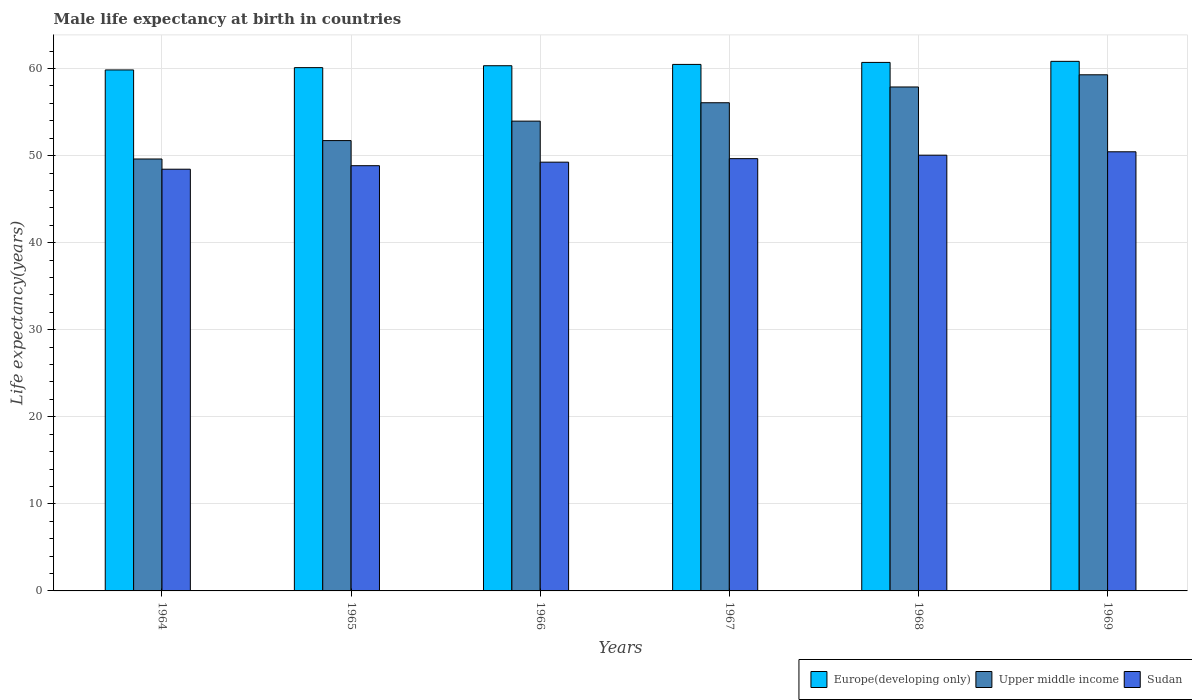How many different coloured bars are there?
Provide a succinct answer. 3. How many groups of bars are there?
Your answer should be compact. 6. Are the number of bars per tick equal to the number of legend labels?
Keep it short and to the point. Yes. Are the number of bars on each tick of the X-axis equal?
Your answer should be very brief. Yes. How many bars are there on the 6th tick from the left?
Offer a very short reply. 3. How many bars are there on the 2nd tick from the right?
Keep it short and to the point. 3. What is the label of the 6th group of bars from the left?
Keep it short and to the point. 1969. In how many cases, is the number of bars for a given year not equal to the number of legend labels?
Make the answer very short. 0. What is the male life expectancy at birth in Sudan in 1964?
Provide a short and direct response. 48.44. Across all years, what is the maximum male life expectancy at birth in Sudan?
Your answer should be very brief. 50.44. Across all years, what is the minimum male life expectancy at birth in Europe(developing only)?
Keep it short and to the point. 59.84. In which year was the male life expectancy at birth in Upper middle income maximum?
Make the answer very short. 1969. In which year was the male life expectancy at birth in Upper middle income minimum?
Provide a short and direct response. 1964. What is the total male life expectancy at birth in Sudan in the graph?
Your answer should be compact. 296.67. What is the difference between the male life expectancy at birth in Upper middle income in 1966 and that in 1969?
Give a very brief answer. -5.32. What is the difference between the male life expectancy at birth in Sudan in 1965 and the male life expectancy at birth in Upper middle income in 1964?
Give a very brief answer. -0.77. What is the average male life expectancy at birth in Sudan per year?
Your answer should be compact. 49.45. In the year 1966, what is the difference between the male life expectancy at birth in Sudan and male life expectancy at birth in Upper middle income?
Offer a very short reply. -4.71. In how many years, is the male life expectancy at birth in Europe(developing only) greater than 20 years?
Ensure brevity in your answer.  6. What is the ratio of the male life expectancy at birth in Sudan in 1966 to that in 1967?
Offer a very short reply. 0.99. Is the male life expectancy at birth in Upper middle income in 1966 less than that in 1969?
Your answer should be compact. Yes. What is the difference between the highest and the second highest male life expectancy at birth in Sudan?
Provide a succinct answer. 0.39. What is the difference between the highest and the lowest male life expectancy at birth in Sudan?
Give a very brief answer. 2. In how many years, is the male life expectancy at birth in Europe(developing only) greater than the average male life expectancy at birth in Europe(developing only) taken over all years?
Your answer should be compact. 3. Is the sum of the male life expectancy at birth in Sudan in 1964 and 1969 greater than the maximum male life expectancy at birth in Upper middle income across all years?
Make the answer very short. Yes. What does the 3rd bar from the left in 1966 represents?
Offer a very short reply. Sudan. What does the 3rd bar from the right in 1965 represents?
Your answer should be very brief. Europe(developing only). Is it the case that in every year, the sum of the male life expectancy at birth in Upper middle income and male life expectancy at birth in Europe(developing only) is greater than the male life expectancy at birth in Sudan?
Your response must be concise. Yes. How many bars are there?
Keep it short and to the point. 18. How many years are there in the graph?
Keep it short and to the point. 6. What is the difference between two consecutive major ticks on the Y-axis?
Your answer should be compact. 10. Does the graph contain grids?
Make the answer very short. Yes. How are the legend labels stacked?
Provide a succinct answer. Horizontal. What is the title of the graph?
Your answer should be very brief. Male life expectancy at birth in countries. Does "Niger" appear as one of the legend labels in the graph?
Your answer should be compact. No. What is the label or title of the Y-axis?
Your answer should be compact. Life expectancy(years). What is the Life expectancy(years) of Europe(developing only) in 1964?
Provide a succinct answer. 59.84. What is the Life expectancy(years) of Upper middle income in 1964?
Give a very brief answer. 49.61. What is the Life expectancy(years) in Sudan in 1964?
Make the answer very short. 48.44. What is the Life expectancy(years) in Europe(developing only) in 1965?
Your response must be concise. 60.11. What is the Life expectancy(years) of Upper middle income in 1965?
Keep it short and to the point. 51.73. What is the Life expectancy(years) in Sudan in 1965?
Keep it short and to the point. 48.84. What is the Life expectancy(years) in Europe(developing only) in 1966?
Provide a short and direct response. 60.33. What is the Life expectancy(years) in Upper middle income in 1966?
Your answer should be very brief. 53.96. What is the Life expectancy(years) in Sudan in 1966?
Your answer should be compact. 49.25. What is the Life expectancy(years) in Europe(developing only) in 1967?
Offer a terse response. 60.48. What is the Life expectancy(years) of Upper middle income in 1967?
Keep it short and to the point. 56.07. What is the Life expectancy(years) of Sudan in 1967?
Offer a very short reply. 49.65. What is the Life expectancy(years) of Europe(developing only) in 1968?
Offer a terse response. 60.71. What is the Life expectancy(years) of Upper middle income in 1968?
Your response must be concise. 57.89. What is the Life expectancy(years) in Sudan in 1968?
Your response must be concise. 50.05. What is the Life expectancy(years) of Europe(developing only) in 1969?
Provide a succinct answer. 60.83. What is the Life expectancy(years) of Upper middle income in 1969?
Your answer should be very brief. 59.28. What is the Life expectancy(years) of Sudan in 1969?
Give a very brief answer. 50.44. Across all years, what is the maximum Life expectancy(years) in Europe(developing only)?
Make the answer very short. 60.83. Across all years, what is the maximum Life expectancy(years) of Upper middle income?
Keep it short and to the point. 59.28. Across all years, what is the maximum Life expectancy(years) in Sudan?
Your answer should be very brief. 50.44. Across all years, what is the minimum Life expectancy(years) in Europe(developing only)?
Your answer should be compact. 59.84. Across all years, what is the minimum Life expectancy(years) in Upper middle income?
Provide a short and direct response. 49.61. Across all years, what is the minimum Life expectancy(years) of Sudan?
Offer a terse response. 48.44. What is the total Life expectancy(years) of Europe(developing only) in the graph?
Make the answer very short. 362.29. What is the total Life expectancy(years) in Upper middle income in the graph?
Provide a succinct answer. 328.55. What is the total Life expectancy(years) in Sudan in the graph?
Your answer should be compact. 296.67. What is the difference between the Life expectancy(years) in Europe(developing only) in 1964 and that in 1965?
Give a very brief answer. -0.27. What is the difference between the Life expectancy(years) of Upper middle income in 1964 and that in 1965?
Ensure brevity in your answer.  -2.11. What is the difference between the Life expectancy(years) in Sudan in 1964 and that in 1965?
Give a very brief answer. -0.4. What is the difference between the Life expectancy(years) of Europe(developing only) in 1964 and that in 1966?
Give a very brief answer. -0.48. What is the difference between the Life expectancy(years) in Upper middle income in 1964 and that in 1966?
Offer a terse response. -4.35. What is the difference between the Life expectancy(years) in Sudan in 1964 and that in 1966?
Make the answer very short. -0.81. What is the difference between the Life expectancy(years) of Europe(developing only) in 1964 and that in 1967?
Provide a short and direct response. -0.64. What is the difference between the Life expectancy(years) in Upper middle income in 1964 and that in 1967?
Offer a terse response. -6.46. What is the difference between the Life expectancy(years) in Sudan in 1964 and that in 1967?
Your answer should be very brief. -1.21. What is the difference between the Life expectancy(years) in Europe(developing only) in 1964 and that in 1968?
Your answer should be very brief. -0.86. What is the difference between the Life expectancy(years) in Upper middle income in 1964 and that in 1968?
Make the answer very short. -8.27. What is the difference between the Life expectancy(years) in Sudan in 1964 and that in 1968?
Offer a terse response. -1.61. What is the difference between the Life expectancy(years) in Europe(developing only) in 1964 and that in 1969?
Give a very brief answer. -0.99. What is the difference between the Life expectancy(years) in Upper middle income in 1964 and that in 1969?
Make the answer very short. -9.67. What is the difference between the Life expectancy(years) of Sudan in 1964 and that in 1969?
Ensure brevity in your answer.  -2. What is the difference between the Life expectancy(years) in Europe(developing only) in 1965 and that in 1966?
Provide a succinct answer. -0.22. What is the difference between the Life expectancy(years) in Upper middle income in 1965 and that in 1966?
Ensure brevity in your answer.  -2.24. What is the difference between the Life expectancy(years) in Sudan in 1965 and that in 1966?
Your answer should be very brief. -0.41. What is the difference between the Life expectancy(years) in Europe(developing only) in 1965 and that in 1967?
Your answer should be compact. -0.37. What is the difference between the Life expectancy(years) in Upper middle income in 1965 and that in 1967?
Your answer should be compact. -4.35. What is the difference between the Life expectancy(years) of Sudan in 1965 and that in 1967?
Keep it short and to the point. -0.81. What is the difference between the Life expectancy(years) of Europe(developing only) in 1965 and that in 1968?
Your response must be concise. -0.6. What is the difference between the Life expectancy(years) of Upper middle income in 1965 and that in 1968?
Your answer should be very brief. -6.16. What is the difference between the Life expectancy(years) in Sudan in 1965 and that in 1968?
Your response must be concise. -1.21. What is the difference between the Life expectancy(years) in Europe(developing only) in 1965 and that in 1969?
Your response must be concise. -0.72. What is the difference between the Life expectancy(years) of Upper middle income in 1965 and that in 1969?
Provide a short and direct response. -7.56. What is the difference between the Life expectancy(years) in Sudan in 1965 and that in 1969?
Your response must be concise. -1.6. What is the difference between the Life expectancy(years) in Europe(developing only) in 1966 and that in 1967?
Your answer should be very brief. -0.15. What is the difference between the Life expectancy(years) in Upper middle income in 1966 and that in 1967?
Make the answer very short. -2.11. What is the difference between the Life expectancy(years) of Sudan in 1966 and that in 1967?
Ensure brevity in your answer.  -0.4. What is the difference between the Life expectancy(years) in Europe(developing only) in 1966 and that in 1968?
Keep it short and to the point. -0.38. What is the difference between the Life expectancy(years) in Upper middle income in 1966 and that in 1968?
Your answer should be compact. -3.92. What is the difference between the Life expectancy(years) of Sudan in 1966 and that in 1968?
Provide a succinct answer. -0.8. What is the difference between the Life expectancy(years) of Europe(developing only) in 1966 and that in 1969?
Your answer should be very brief. -0.5. What is the difference between the Life expectancy(years) of Upper middle income in 1966 and that in 1969?
Keep it short and to the point. -5.32. What is the difference between the Life expectancy(years) of Sudan in 1966 and that in 1969?
Offer a very short reply. -1.19. What is the difference between the Life expectancy(years) of Europe(developing only) in 1967 and that in 1968?
Keep it short and to the point. -0.23. What is the difference between the Life expectancy(years) in Upper middle income in 1967 and that in 1968?
Offer a very short reply. -1.81. What is the difference between the Life expectancy(years) in Sudan in 1967 and that in 1968?
Offer a terse response. -0.4. What is the difference between the Life expectancy(years) of Europe(developing only) in 1967 and that in 1969?
Provide a short and direct response. -0.35. What is the difference between the Life expectancy(years) in Upper middle income in 1967 and that in 1969?
Provide a short and direct response. -3.21. What is the difference between the Life expectancy(years) of Sudan in 1967 and that in 1969?
Offer a terse response. -0.79. What is the difference between the Life expectancy(years) of Europe(developing only) in 1968 and that in 1969?
Your response must be concise. -0.12. What is the difference between the Life expectancy(years) of Upper middle income in 1968 and that in 1969?
Ensure brevity in your answer.  -1.4. What is the difference between the Life expectancy(years) in Sudan in 1968 and that in 1969?
Offer a very short reply. -0.39. What is the difference between the Life expectancy(years) in Europe(developing only) in 1964 and the Life expectancy(years) in Upper middle income in 1965?
Give a very brief answer. 8.12. What is the difference between the Life expectancy(years) in Europe(developing only) in 1964 and the Life expectancy(years) in Sudan in 1965?
Offer a very short reply. 11. What is the difference between the Life expectancy(years) in Upper middle income in 1964 and the Life expectancy(years) in Sudan in 1965?
Offer a terse response. 0.77. What is the difference between the Life expectancy(years) in Europe(developing only) in 1964 and the Life expectancy(years) in Upper middle income in 1966?
Offer a terse response. 5.88. What is the difference between the Life expectancy(years) in Europe(developing only) in 1964 and the Life expectancy(years) in Sudan in 1966?
Provide a succinct answer. 10.59. What is the difference between the Life expectancy(years) in Upper middle income in 1964 and the Life expectancy(years) in Sudan in 1966?
Ensure brevity in your answer.  0.37. What is the difference between the Life expectancy(years) of Europe(developing only) in 1964 and the Life expectancy(years) of Upper middle income in 1967?
Your answer should be compact. 3.77. What is the difference between the Life expectancy(years) in Europe(developing only) in 1964 and the Life expectancy(years) in Sudan in 1967?
Offer a terse response. 10.19. What is the difference between the Life expectancy(years) of Upper middle income in 1964 and the Life expectancy(years) of Sudan in 1967?
Ensure brevity in your answer.  -0.04. What is the difference between the Life expectancy(years) of Europe(developing only) in 1964 and the Life expectancy(years) of Upper middle income in 1968?
Your answer should be compact. 1.96. What is the difference between the Life expectancy(years) of Europe(developing only) in 1964 and the Life expectancy(years) of Sudan in 1968?
Give a very brief answer. 9.79. What is the difference between the Life expectancy(years) in Upper middle income in 1964 and the Life expectancy(years) in Sudan in 1968?
Your answer should be compact. -0.44. What is the difference between the Life expectancy(years) of Europe(developing only) in 1964 and the Life expectancy(years) of Upper middle income in 1969?
Offer a very short reply. 0.56. What is the difference between the Life expectancy(years) of Europe(developing only) in 1964 and the Life expectancy(years) of Sudan in 1969?
Ensure brevity in your answer.  9.4. What is the difference between the Life expectancy(years) of Upper middle income in 1964 and the Life expectancy(years) of Sudan in 1969?
Provide a short and direct response. -0.83. What is the difference between the Life expectancy(years) of Europe(developing only) in 1965 and the Life expectancy(years) of Upper middle income in 1966?
Provide a short and direct response. 6.14. What is the difference between the Life expectancy(years) of Europe(developing only) in 1965 and the Life expectancy(years) of Sudan in 1966?
Keep it short and to the point. 10.86. What is the difference between the Life expectancy(years) in Upper middle income in 1965 and the Life expectancy(years) in Sudan in 1966?
Your response must be concise. 2.48. What is the difference between the Life expectancy(years) of Europe(developing only) in 1965 and the Life expectancy(years) of Upper middle income in 1967?
Your response must be concise. 4.03. What is the difference between the Life expectancy(years) of Europe(developing only) in 1965 and the Life expectancy(years) of Sudan in 1967?
Provide a short and direct response. 10.46. What is the difference between the Life expectancy(years) of Upper middle income in 1965 and the Life expectancy(years) of Sudan in 1967?
Provide a succinct answer. 2.07. What is the difference between the Life expectancy(years) in Europe(developing only) in 1965 and the Life expectancy(years) in Upper middle income in 1968?
Your response must be concise. 2.22. What is the difference between the Life expectancy(years) of Europe(developing only) in 1965 and the Life expectancy(years) of Sudan in 1968?
Your answer should be compact. 10.06. What is the difference between the Life expectancy(years) in Upper middle income in 1965 and the Life expectancy(years) in Sudan in 1968?
Give a very brief answer. 1.68. What is the difference between the Life expectancy(years) of Europe(developing only) in 1965 and the Life expectancy(years) of Upper middle income in 1969?
Your response must be concise. 0.82. What is the difference between the Life expectancy(years) of Europe(developing only) in 1965 and the Life expectancy(years) of Sudan in 1969?
Keep it short and to the point. 9.67. What is the difference between the Life expectancy(years) in Upper middle income in 1965 and the Life expectancy(years) in Sudan in 1969?
Your response must be concise. 1.29. What is the difference between the Life expectancy(years) of Europe(developing only) in 1966 and the Life expectancy(years) of Upper middle income in 1967?
Ensure brevity in your answer.  4.25. What is the difference between the Life expectancy(years) in Europe(developing only) in 1966 and the Life expectancy(years) in Sudan in 1967?
Keep it short and to the point. 10.67. What is the difference between the Life expectancy(years) of Upper middle income in 1966 and the Life expectancy(years) of Sudan in 1967?
Make the answer very short. 4.31. What is the difference between the Life expectancy(years) in Europe(developing only) in 1966 and the Life expectancy(years) in Upper middle income in 1968?
Your response must be concise. 2.44. What is the difference between the Life expectancy(years) in Europe(developing only) in 1966 and the Life expectancy(years) in Sudan in 1968?
Ensure brevity in your answer.  10.28. What is the difference between the Life expectancy(years) in Upper middle income in 1966 and the Life expectancy(years) in Sudan in 1968?
Offer a very short reply. 3.91. What is the difference between the Life expectancy(years) of Europe(developing only) in 1966 and the Life expectancy(years) of Upper middle income in 1969?
Your answer should be very brief. 1.04. What is the difference between the Life expectancy(years) in Europe(developing only) in 1966 and the Life expectancy(years) in Sudan in 1969?
Offer a terse response. 9.89. What is the difference between the Life expectancy(years) in Upper middle income in 1966 and the Life expectancy(years) in Sudan in 1969?
Offer a very short reply. 3.52. What is the difference between the Life expectancy(years) of Europe(developing only) in 1967 and the Life expectancy(years) of Upper middle income in 1968?
Keep it short and to the point. 2.59. What is the difference between the Life expectancy(years) of Europe(developing only) in 1967 and the Life expectancy(years) of Sudan in 1968?
Make the answer very short. 10.43. What is the difference between the Life expectancy(years) in Upper middle income in 1967 and the Life expectancy(years) in Sudan in 1968?
Ensure brevity in your answer.  6.02. What is the difference between the Life expectancy(years) in Europe(developing only) in 1967 and the Life expectancy(years) in Upper middle income in 1969?
Make the answer very short. 1.19. What is the difference between the Life expectancy(years) in Europe(developing only) in 1967 and the Life expectancy(years) in Sudan in 1969?
Your answer should be very brief. 10.04. What is the difference between the Life expectancy(years) of Upper middle income in 1967 and the Life expectancy(years) of Sudan in 1969?
Give a very brief answer. 5.63. What is the difference between the Life expectancy(years) in Europe(developing only) in 1968 and the Life expectancy(years) in Upper middle income in 1969?
Keep it short and to the point. 1.42. What is the difference between the Life expectancy(years) of Europe(developing only) in 1968 and the Life expectancy(years) of Sudan in 1969?
Ensure brevity in your answer.  10.27. What is the difference between the Life expectancy(years) of Upper middle income in 1968 and the Life expectancy(years) of Sudan in 1969?
Your response must be concise. 7.45. What is the average Life expectancy(years) of Europe(developing only) per year?
Your answer should be very brief. 60.38. What is the average Life expectancy(years) in Upper middle income per year?
Offer a very short reply. 54.76. What is the average Life expectancy(years) in Sudan per year?
Your answer should be compact. 49.45. In the year 1964, what is the difference between the Life expectancy(years) of Europe(developing only) and Life expectancy(years) of Upper middle income?
Offer a terse response. 10.23. In the year 1964, what is the difference between the Life expectancy(years) of Europe(developing only) and Life expectancy(years) of Sudan?
Your response must be concise. 11.4. In the year 1964, what is the difference between the Life expectancy(years) in Upper middle income and Life expectancy(years) in Sudan?
Offer a very short reply. 1.17. In the year 1965, what is the difference between the Life expectancy(years) in Europe(developing only) and Life expectancy(years) in Upper middle income?
Give a very brief answer. 8.38. In the year 1965, what is the difference between the Life expectancy(years) in Europe(developing only) and Life expectancy(years) in Sudan?
Provide a succinct answer. 11.26. In the year 1965, what is the difference between the Life expectancy(years) in Upper middle income and Life expectancy(years) in Sudan?
Provide a succinct answer. 2.88. In the year 1966, what is the difference between the Life expectancy(years) of Europe(developing only) and Life expectancy(years) of Upper middle income?
Your answer should be very brief. 6.36. In the year 1966, what is the difference between the Life expectancy(years) in Europe(developing only) and Life expectancy(years) in Sudan?
Offer a very short reply. 11.08. In the year 1966, what is the difference between the Life expectancy(years) in Upper middle income and Life expectancy(years) in Sudan?
Provide a short and direct response. 4.71. In the year 1967, what is the difference between the Life expectancy(years) in Europe(developing only) and Life expectancy(years) in Upper middle income?
Make the answer very short. 4.4. In the year 1967, what is the difference between the Life expectancy(years) in Europe(developing only) and Life expectancy(years) in Sudan?
Your response must be concise. 10.83. In the year 1967, what is the difference between the Life expectancy(years) in Upper middle income and Life expectancy(years) in Sudan?
Give a very brief answer. 6.42. In the year 1968, what is the difference between the Life expectancy(years) of Europe(developing only) and Life expectancy(years) of Upper middle income?
Provide a succinct answer. 2.82. In the year 1968, what is the difference between the Life expectancy(years) of Europe(developing only) and Life expectancy(years) of Sudan?
Provide a short and direct response. 10.66. In the year 1968, what is the difference between the Life expectancy(years) in Upper middle income and Life expectancy(years) in Sudan?
Provide a succinct answer. 7.83. In the year 1969, what is the difference between the Life expectancy(years) in Europe(developing only) and Life expectancy(years) in Upper middle income?
Your response must be concise. 1.54. In the year 1969, what is the difference between the Life expectancy(years) of Europe(developing only) and Life expectancy(years) of Sudan?
Offer a very short reply. 10.39. In the year 1969, what is the difference between the Life expectancy(years) of Upper middle income and Life expectancy(years) of Sudan?
Your answer should be very brief. 8.84. What is the ratio of the Life expectancy(years) in Europe(developing only) in 1964 to that in 1965?
Offer a terse response. 1. What is the ratio of the Life expectancy(years) of Upper middle income in 1964 to that in 1965?
Give a very brief answer. 0.96. What is the ratio of the Life expectancy(years) of Upper middle income in 1964 to that in 1966?
Keep it short and to the point. 0.92. What is the ratio of the Life expectancy(years) of Sudan in 1964 to that in 1966?
Keep it short and to the point. 0.98. What is the ratio of the Life expectancy(years) in Europe(developing only) in 1964 to that in 1967?
Keep it short and to the point. 0.99. What is the ratio of the Life expectancy(years) in Upper middle income in 1964 to that in 1967?
Provide a short and direct response. 0.88. What is the ratio of the Life expectancy(years) of Sudan in 1964 to that in 1967?
Offer a terse response. 0.98. What is the ratio of the Life expectancy(years) in Europe(developing only) in 1964 to that in 1968?
Offer a terse response. 0.99. What is the ratio of the Life expectancy(years) of Sudan in 1964 to that in 1968?
Provide a succinct answer. 0.97. What is the ratio of the Life expectancy(years) of Europe(developing only) in 1964 to that in 1969?
Provide a succinct answer. 0.98. What is the ratio of the Life expectancy(years) in Upper middle income in 1964 to that in 1969?
Your response must be concise. 0.84. What is the ratio of the Life expectancy(years) of Sudan in 1964 to that in 1969?
Ensure brevity in your answer.  0.96. What is the ratio of the Life expectancy(years) of Upper middle income in 1965 to that in 1966?
Offer a terse response. 0.96. What is the ratio of the Life expectancy(years) of Upper middle income in 1965 to that in 1967?
Your answer should be very brief. 0.92. What is the ratio of the Life expectancy(years) of Sudan in 1965 to that in 1967?
Your answer should be compact. 0.98. What is the ratio of the Life expectancy(years) of Europe(developing only) in 1965 to that in 1968?
Make the answer very short. 0.99. What is the ratio of the Life expectancy(years) in Upper middle income in 1965 to that in 1968?
Your answer should be compact. 0.89. What is the ratio of the Life expectancy(years) of Sudan in 1965 to that in 1968?
Your answer should be compact. 0.98. What is the ratio of the Life expectancy(years) of Upper middle income in 1965 to that in 1969?
Make the answer very short. 0.87. What is the ratio of the Life expectancy(years) of Sudan in 1965 to that in 1969?
Give a very brief answer. 0.97. What is the ratio of the Life expectancy(years) in Upper middle income in 1966 to that in 1967?
Your answer should be compact. 0.96. What is the ratio of the Life expectancy(years) in Sudan in 1966 to that in 1967?
Make the answer very short. 0.99. What is the ratio of the Life expectancy(years) in Europe(developing only) in 1966 to that in 1968?
Your answer should be compact. 0.99. What is the ratio of the Life expectancy(years) in Upper middle income in 1966 to that in 1968?
Make the answer very short. 0.93. What is the ratio of the Life expectancy(years) in Upper middle income in 1966 to that in 1969?
Your response must be concise. 0.91. What is the ratio of the Life expectancy(years) in Sudan in 1966 to that in 1969?
Offer a very short reply. 0.98. What is the ratio of the Life expectancy(years) of Europe(developing only) in 1967 to that in 1968?
Make the answer very short. 1. What is the ratio of the Life expectancy(years) in Upper middle income in 1967 to that in 1968?
Make the answer very short. 0.97. What is the ratio of the Life expectancy(years) of Sudan in 1967 to that in 1968?
Offer a terse response. 0.99. What is the ratio of the Life expectancy(years) of Upper middle income in 1967 to that in 1969?
Your answer should be compact. 0.95. What is the ratio of the Life expectancy(years) of Sudan in 1967 to that in 1969?
Provide a succinct answer. 0.98. What is the ratio of the Life expectancy(years) of Europe(developing only) in 1968 to that in 1969?
Give a very brief answer. 1. What is the ratio of the Life expectancy(years) of Upper middle income in 1968 to that in 1969?
Your answer should be compact. 0.98. What is the difference between the highest and the second highest Life expectancy(years) in Europe(developing only)?
Offer a terse response. 0.12. What is the difference between the highest and the second highest Life expectancy(years) in Upper middle income?
Your answer should be compact. 1.4. What is the difference between the highest and the second highest Life expectancy(years) in Sudan?
Your response must be concise. 0.39. What is the difference between the highest and the lowest Life expectancy(years) of Europe(developing only)?
Your response must be concise. 0.99. What is the difference between the highest and the lowest Life expectancy(years) in Upper middle income?
Keep it short and to the point. 9.67. What is the difference between the highest and the lowest Life expectancy(years) in Sudan?
Your answer should be compact. 2. 